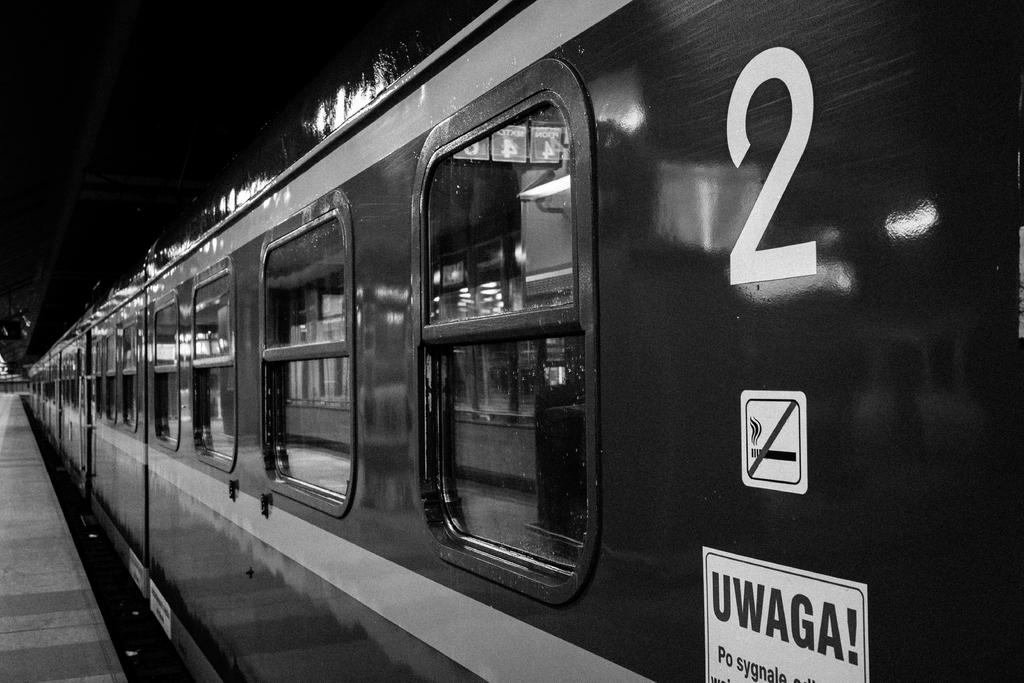<image>
Share a concise interpretation of the image provided. A train with the number 2 and the word UWAGA on it. 